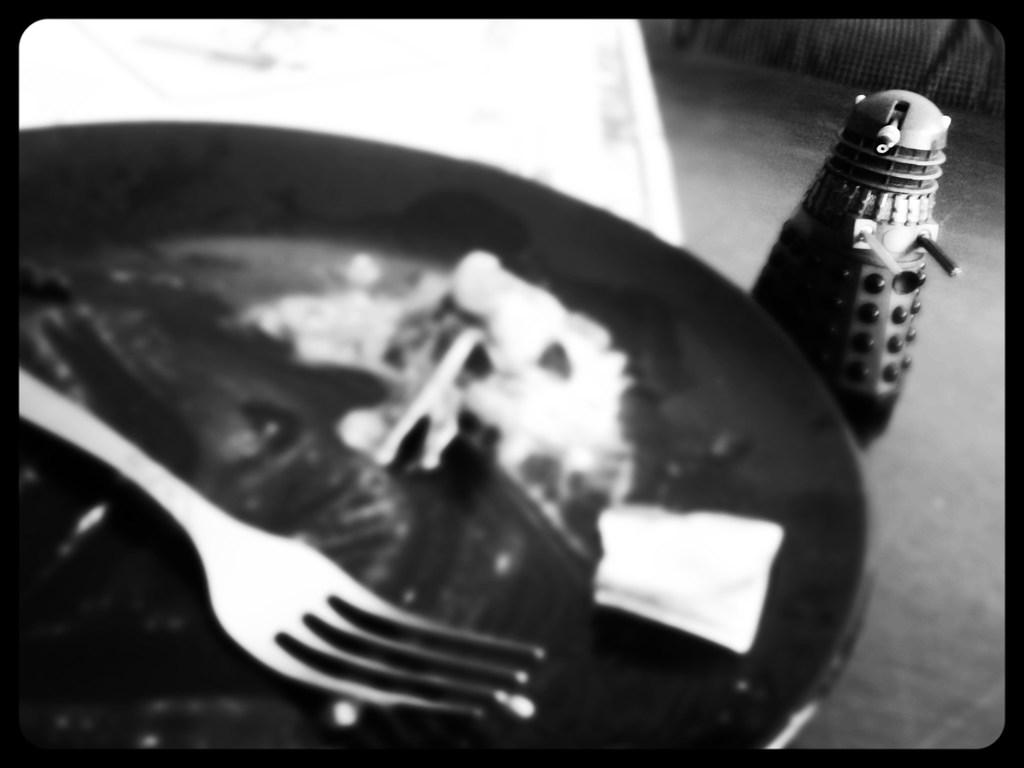What utensil can be seen in the plate in the image? There is a fork in the plate in the image. What color scheme is used in the image? The image is in black and white color. What type of weather can be seen in the image? There is no weather depicted in the image, as it is in black and white color and does not show any outdoor elements. 